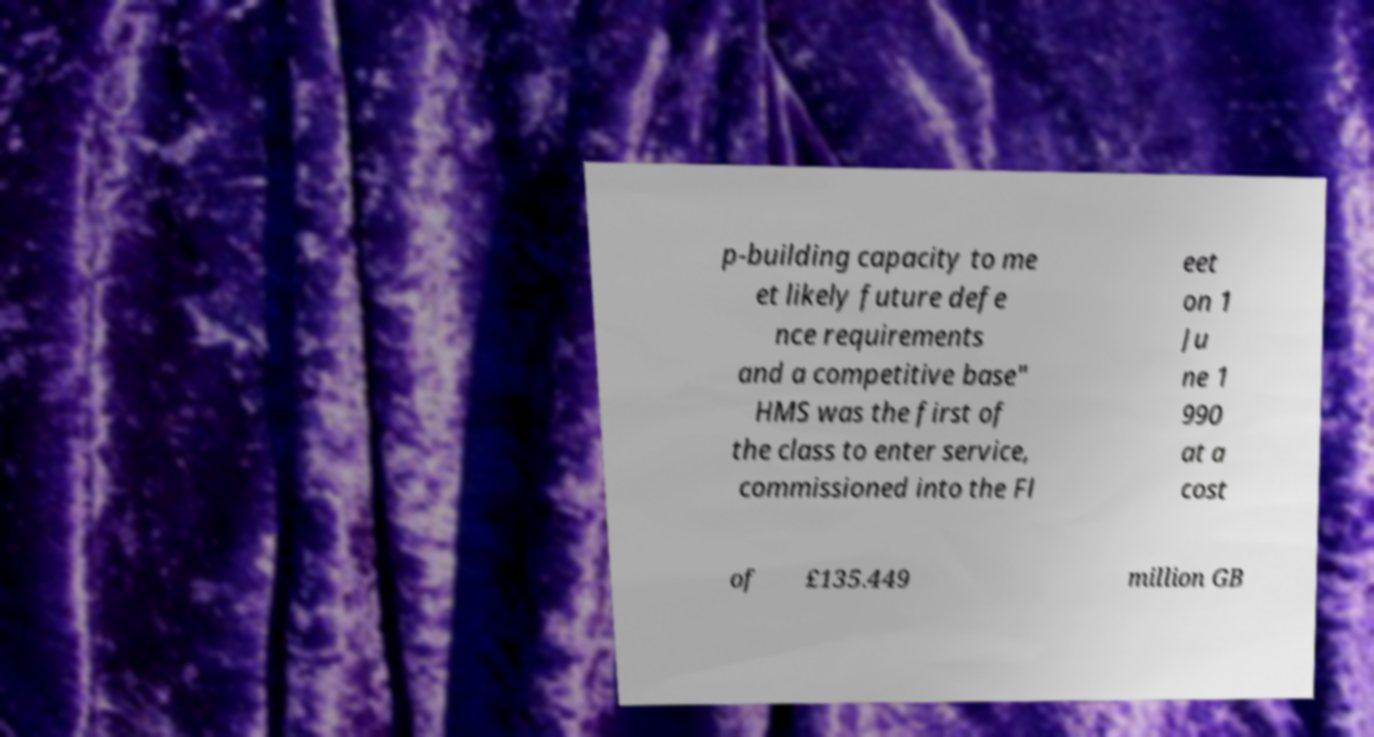Could you assist in decoding the text presented in this image and type it out clearly? p-building capacity to me et likely future defe nce requirements and a competitive base" HMS was the first of the class to enter service, commissioned into the Fl eet on 1 Ju ne 1 990 at a cost of £135.449 million GB 